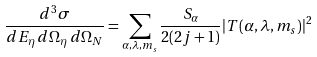Convert formula to latex. <formula><loc_0><loc_0><loc_500><loc_500>\frac { d ^ { 3 } \sigma } { d E _ { \eta } \, d \Omega _ { \eta } \, d \Omega _ { N } } = \sum _ { \alpha , \lambda , m _ { s } } \frac { S _ { \alpha } } { 2 ( 2 j + 1 ) } | T ( \alpha , \lambda , m _ { s } ) | ^ { 2 }</formula> 